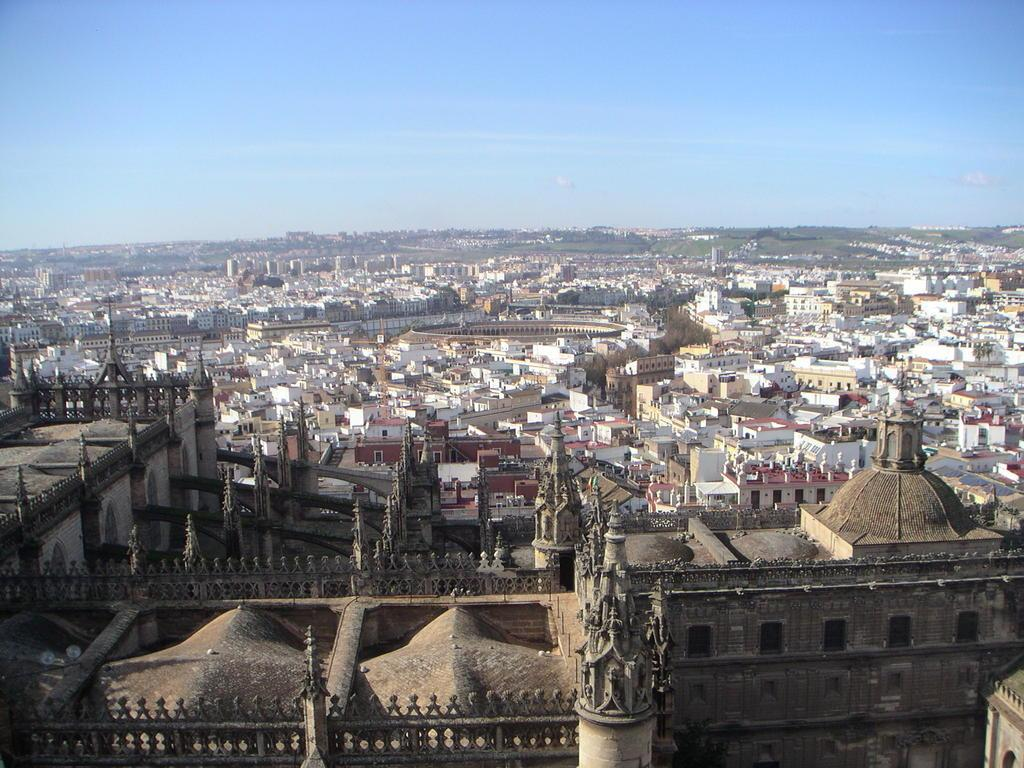What type of structures can be seen in the image? There are buildings in the image. What other natural elements are present in the image? There are trees in the image. Can you describe any specific architectural features in the image? There is an ancient architecture in the image. What is visible at the top of the image? The sky is visible at the top of the image. How many pears can be seen hanging from the trees in the image? There are no pears present in the image; it features buildings, trees, and ancient architecture. What type of tail is visible on the buildings in the image? There are no tails visible on the buildings in the image. 